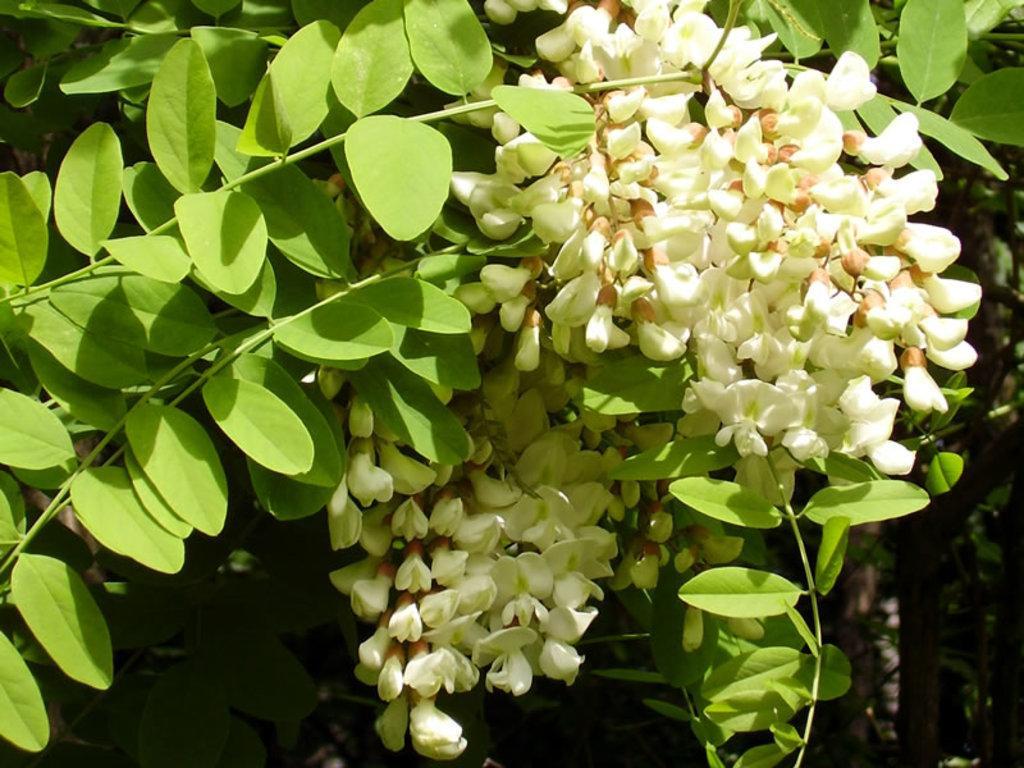In one or two sentences, can you explain what this image depicts? In the middle of this image, there are branches having white color flowers and green color leaves. And the background is dark in color. 